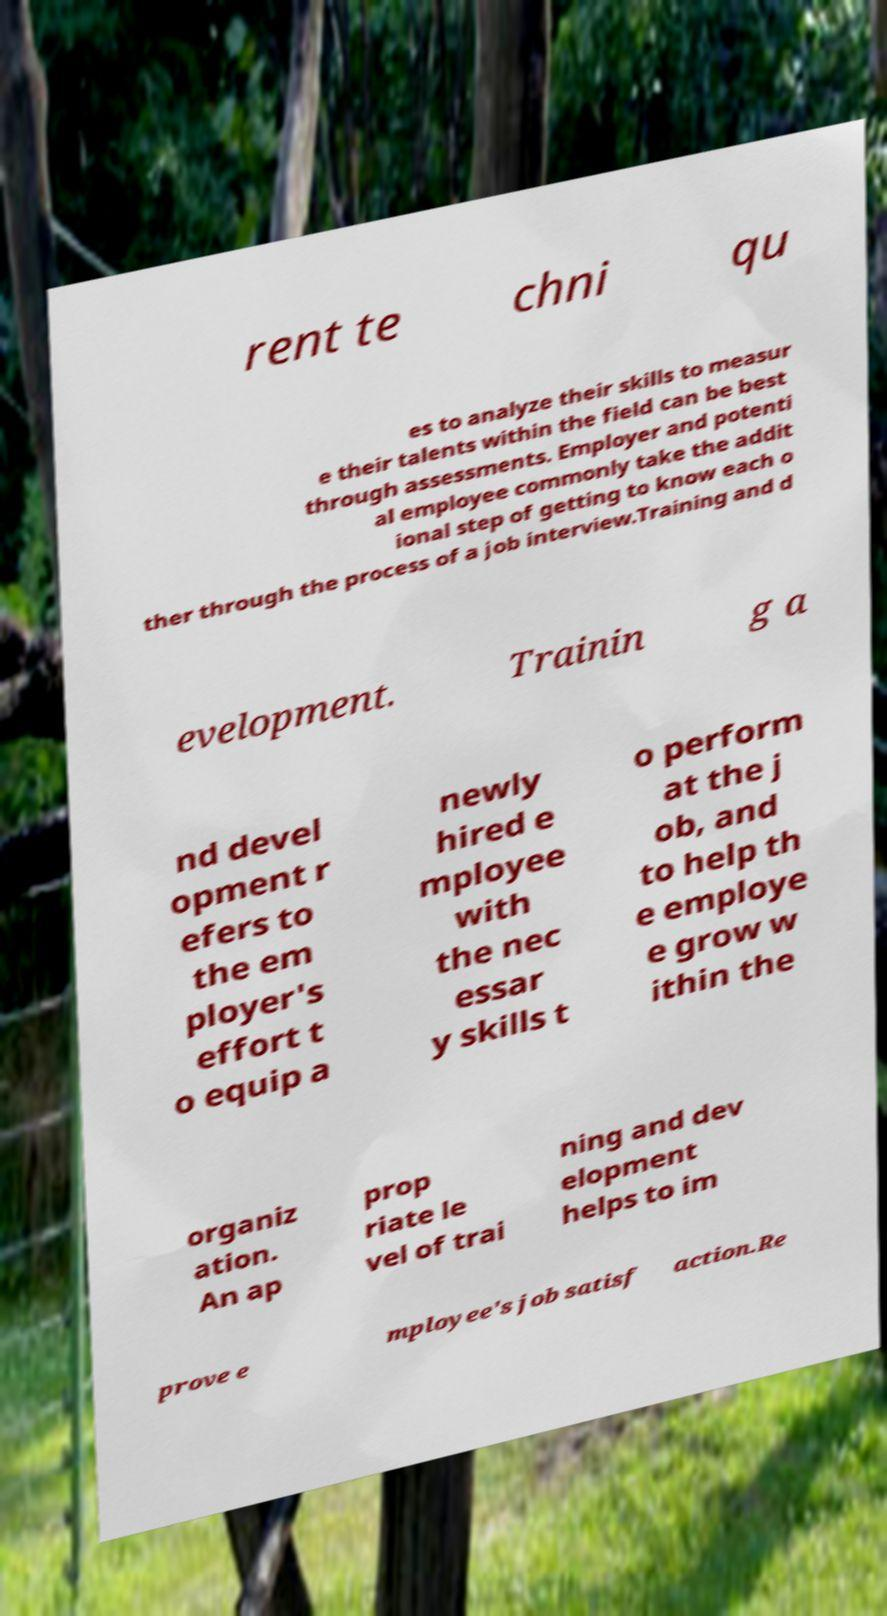Can you read and provide the text displayed in the image?This photo seems to have some interesting text. Can you extract and type it out for me? rent te chni qu es to analyze their skills to measur e their talents within the field can be best through assessments. Employer and potenti al employee commonly take the addit ional step of getting to know each o ther through the process of a job interview.Training and d evelopment. Trainin g a nd devel opment r efers to the em ployer's effort t o equip a newly hired e mployee with the nec essar y skills t o perform at the j ob, and to help th e employe e grow w ithin the organiz ation. An ap prop riate le vel of trai ning and dev elopment helps to im prove e mployee's job satisf action.Re 